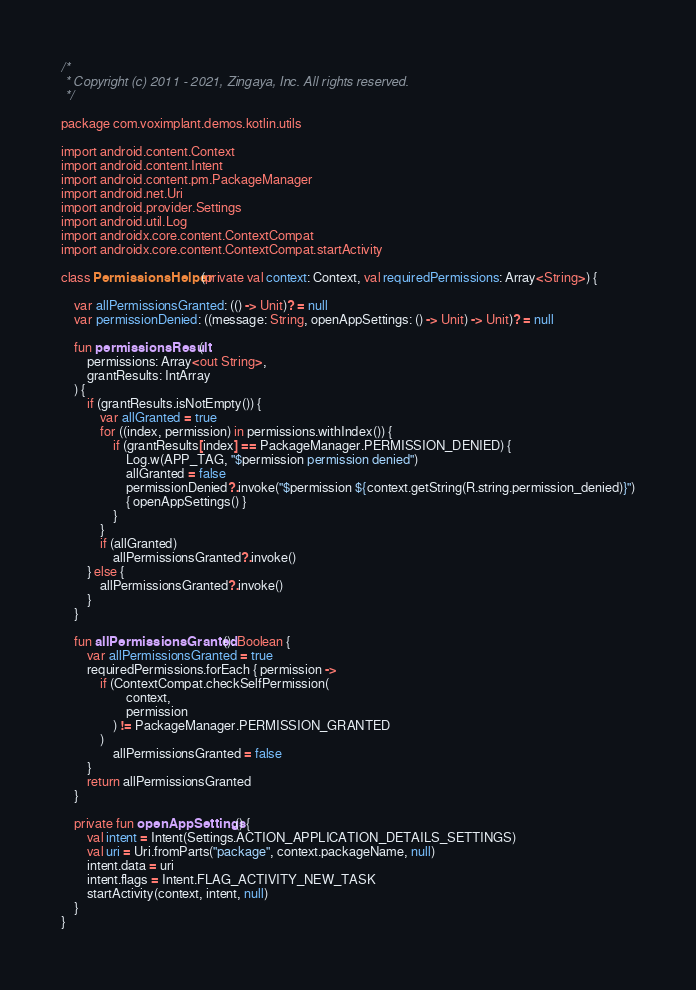<code> <loc_0><loc_0><loc_500><loc_500><_Kotlin_>/*
 * Copyright (c) 2011 - 2021, Zingaya, Inc. All rights reserved.
 */

package com.voximplant.demos.kotlin.utils

import android.content.Context
import android.content.Intent
import android.content.pm.PackageManager
import android.net.Uri
import android.provider.Settings
import android.util.Log
import androidx.core.content.ContextCompat
import androidx.core.content.ContextCompat.startActivity

class PermissionsHelper(private val context: Context, val requiredPermissions: Array<String>) {

    var allPermissionsGranted: (() -> Unit)? = null
    var permissionDenied: ((message: String, openAppSettings: () -> Unit) -> Unit)? = null

    fun permissionsResult(
        permissions: Array<out String>,
        grantResults: IntArray
    ) {
        if (grantResults.isNotEmpty()) {
            var allGranted = true
            for ((index, permission) in permissions.withIndex()) {
                if (grantResults[index] == PackageManager.PERMISSION_DENIED) {
                    Log.w(APP_TAG, "$permission permission denied")
                    allGranted = false
                    permissionDenied?.invoke("$permission ${context.getString(R.string.permission_denied)}")
                    { openAppSettings() }
                }
            }
            if (allGranted)
                allPermissionsGranted?.invoke()
        } else {
            allPermissionsGranted?.invoke()
        }
    }

    fun allPermissionsGranted(): Boolean {
        var allPermissionsGranted = true
        requiredPermissions.forEach { permission ->
            if (ContextCompat.checkSelfPermission(
                    context,
                    permission
                ) != PackageManager.PERMISSION_GRANTED
            )
                allPermissionsGranted = false
        }
        return allPermissionsGranted
    }

    private fun openAppSettings() {
        val intent = Intent(Settings.ACTION_APPLICATION_DETAILS_SETTINGS)
        val uri = Uri.fromParts("package", context.packageName, null)
        intent.data = uri
        intent.flags = Intent.FLAG_ACTIVITY_NEW_TASK
        startActivity(context, intent, null)
    }
}</code> 